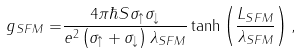<formula> <loc_0><loc_0><loc_500><loc_500>g _ { S F M } = & \frac { 4 \pi \hbar { S } \sigma _ { \uparrow } \sigma _ { \downarrow } } { e ^ { 2 } \left ( \sigma _ { \uparrow } + \sigma _ { \downarrow } \right ) \lambda _ { S F M } } \tanh \left ( \frac { L _ { S F M } } { \lambda _ { S F M } } \right ) ,</formula> 